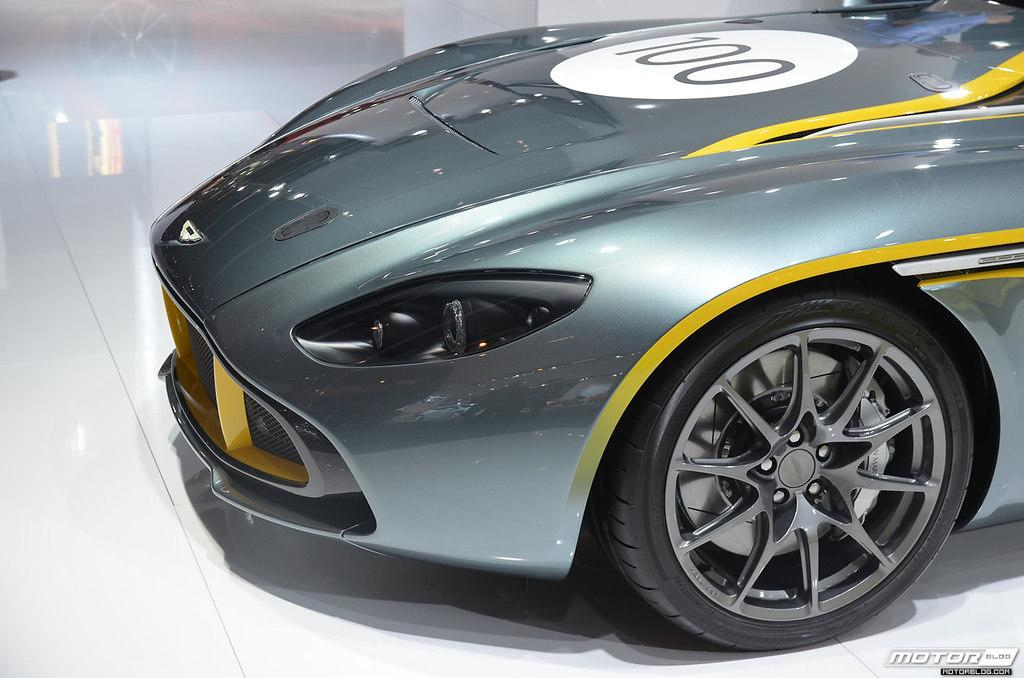What is the main subject of the image? There is a car in the image. Are there any words or phrases in the image? Yes, there is text written in the image. Can you identify any additional features in the image? There is a watermark in the image. What type of corn can be seen growing near the car in the image? There is no corn present in the image; it only features a car, text, and a watermark. 